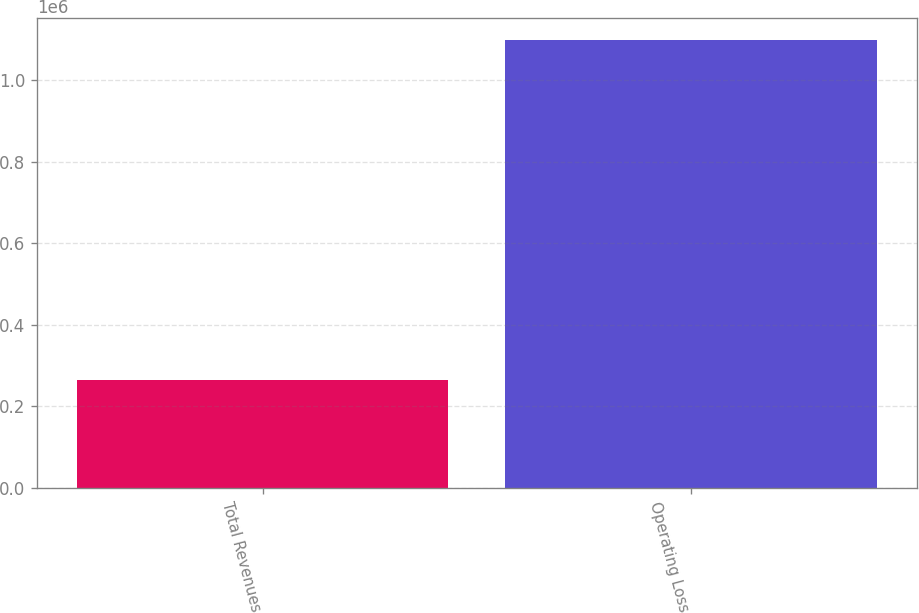<chart> <loc_0><loc_0><loc_500><loc_500><bar_chart><fcel>Total Revenues<fcel>Operating Loss<nl><fcel>264900<fcel>1.09768e+06<nl></chart> 